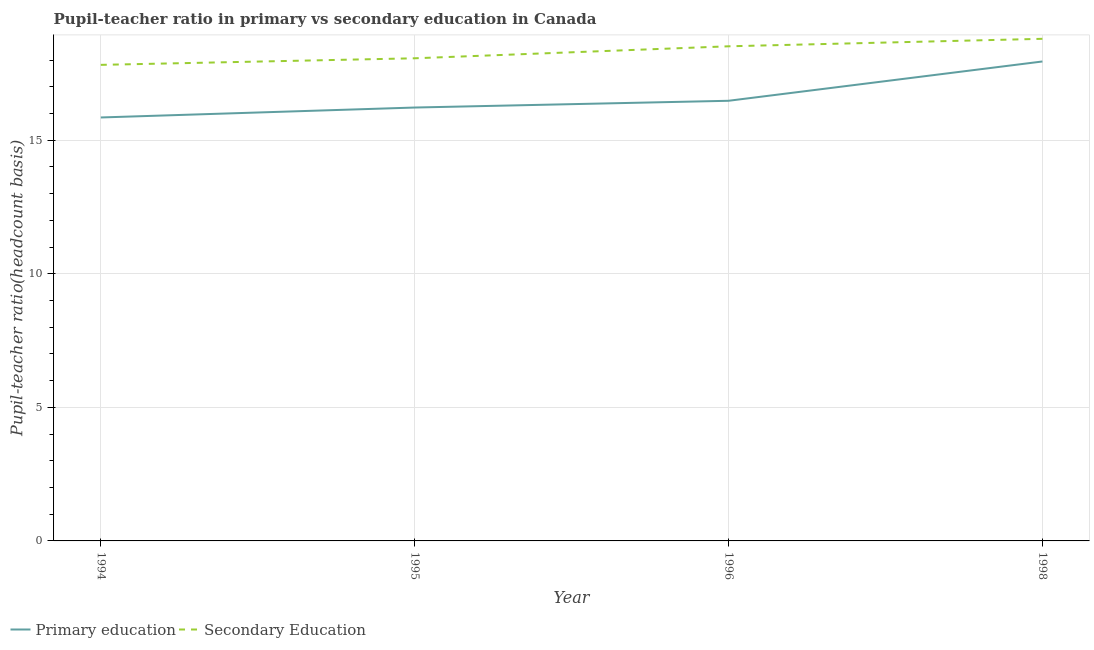Does the line corresponding to pupil-teacher ratio in primary education intersect with the line corresponding to pupil teacher ratio on secondary education?
Provide a succinct answer. No. Is the number of lines equal to the number of legend labels?
Ensure brevity in your answer.  Yes. What is the pupil-teacher ratio in primary education in 1994?
Give a very brief answer. 15.85. Across all years, what is the maximum pupil teacher ratio on secondary education?
Keep it short and to the point. 18.8. Across all years, what is the minimum pupil teacher ratio on secondary education?
Keep it short and to the point. 17.82. In which year was the pupil-teacher ratio in primary education minimum?
Ensure brevity in your answer.  1994. What is the total pupil teacher ratio on secondary education in the graph?
Your answer should be very brief. 73.21. What is the difference between the pupil-teacher ratio in primary education in 1995 and that in 1996?
Your response must be concise. -0.25. What is the difference between the pupil-teacher ratio in primary education in 1996 and the pupil teacher ratio on secondary education in 1994?
Provide a short and direct response. -1.34. What is the average pupil teacher ratio on secondary education per year?
Offer a very short reply. 18.3. In the year 1996, what is the difference between the pupil-teacher ratio in primary education and pupil teacher ratio on secondary education?
Ensure brevity in your answer.  -2.04. What is the ratio of the pupil-teacher ratio in primary education in 1995 to that in 1996?
Your response must be concise. 0.98. Is the difference between the pupil-teacher ratio in primary education in 1996 and 1998 greater than the difference between the pupil teacher ratio on secondary education in 1996 and 1998?
Keep it short and to the point. No. What is the difference between the highest and the second highest pupil-teacher ratio in primary education?
Your response must be concise. 1.47. What is the difference between the highest and the lowest pupil teacher ratio on secondary education?
Your answer should be very brief. 0.98. In how many years, is the pupil teacher ratio on secondary education greater than the average pupil teacher ratio on secondary education taken over all years?
Your response must be concise. 2. Does the pupil-teacher ratio in primary education monotonically increase over the years?
Your response must be concise. Yes. Is the pupil teacher ratio on secondary education strictly greater than the pupil-teacher ratio in primary education over the years?
Your answer should be very brief. Yes. How many years are there in the graph?
Keep it short and to the point. 4. What is the difference between two consecutive major ticks on the Y-axis?
Give a very brief answer. 5. Are the values on the major ticks of Y-axis written in scientific E-notation?
Offer a very short reply. No. How are the legend labels stacked?
Provide a succinct answer. Horizontal. What is the title of the graph?
Give a very brief answer. Pupil-teacher ratio in primary vs secondary education in Canada. What is the label or title of the X-axis?
Provide a succinct answer. Year. What is the label or title of the Y-axis?
Your answer should be compact. Pupil-teacher ratio(headcount basis). What is the Pupil-teacher ratio(headcount basis) of Primary education in 1994?
Keep it short and to the point. 15.85. What is the Pupil-teacher ratio(headcount basis) of Secondary Education in 1994?
Offer a terse response. 17.82. What is the Pupil-teacher ratio(headcount basis) in Primary education in 1995?
Ensure brevity in your answer.  16.23. What is the Pupil-teacher ratio(headcount basis) of Secondary Education in 1995?
Your answer should be very brief. 18.07. What is the Pupil-teacher ratio(headcount basis) in Primary education in 1996?
Your response must be concise. 16.48. What is the Pupil-teacher ratio(headcount basis) in Secondary Education in 1996?
Offer a very short reply. 18.52. What is the Pupil-teacher ratio(headcount basis) of Primary education in 1998?
Your response must be concise. 17.95. What is the Pupil-teacher ratio(headcount basis) of Secondary Education in 1998?
Offer a very short reply. 18.8. Across all years, what is the maximum Pupil-teacher ratio(headcount basis) in Primary education?
Offer a very short reply. 17.95. Across all years, what is the maximum Pupil-teacher ratio(headcount basis) in Secondary Education?
Your response must be concise. 18.8. Across all years, what is the minimum Pupil-teacher ratio(headcount basis) in Primary education?
Keep it short and to the point. 15.85. Across all years, what is the minimum Pupil-teacher ratio(headcount basis) in Secondary Education?
Your response must be concise. 17.82. What is the total Pupil-teacher ratio(headcount basis) of Primary education in the graph?
Provide a succinct answer. 66.51. What is the total Pupil-teacher ratio(headcount basis) of Secondary Education in the graph?
Make the answer very short. 73.21. What is the difference between the Pupil-teacher ratio(headcount basis) of Primary education in 1994 and that in 1995?
Your answer should be compact. -0.37. What is the difference between the Pupil-teacher ratio(headcount basis) in Secondary Education in 1994 and that in 1995?
Offer a terse response. -0.25. What is the difference between the Pupil-teacher ratio(headcount basis) of Primary education in 1994 and that in 1996?
Make the answer very short. -0.62. What is the difference between the Pupil-teacher ratio(headcount basis) in Secondary Education in 1994 and that in 1996?
Provide a short and direct response. -0.7. What is the difference between the Pupil-teacher ratio(headcount basis) of Primary education in 1994 and that in 1998?
Ensure brevity in your answer.  -2.1. What is the difference between the Pupil-teacher ratio(headcount basis) in Secondary Education in 1994 and that in 1998?
Ensure brevity in your answer.  -0.98. What is the difference between the Pupil-teacher ratio(headcount basis) in Primary education in 1995 and that in 1996?
Make the answer very short. -0.25. What is the difference between the Pupil-teacher ratio(headcount basis) in Secondary Education in 1995 and that in 1996?
Provide a short and direct response. -0.45. What is the difference between the Pupil-teacher ratio(headcount basis) of Primary education in 1995 and that in 1998?
Offer a very short reply. -1.72. What is the difference between the Pupil-teacher ratio(headcount basis) of Secondary Education in 1995 and that in 1998?
Ensure brevity in your answer.  -0.73. What is the difference between the Pupil-teacher ratio(headcount basis) in Primary education in 1996 and that in 1998?
Make the answer very short. -1.47. What is the difference between the Pupil-teacher ratio(headcount basis) of Secondary Education in 1996 and that in 1998?
Keep it short and to the point. -0.28. What is the difference between the Pupil-teacher ratio(headcount basis) in Primary education in 1994 and the Pupil-teacher ratio(headcount basis) in Secondary Education in 1995?
Offer a terse response. -2.22. What is the difference between the Pupil-teacher ratio(headcount basis) of Primary education in 1994 and the Pupil-teacher ratio(headcount basis) of Secondary Education in 1996?
Provide a succinct answer. -2.66. What is the difference between the Pupil-teacher ratio(headcount basis) in Primary education in 1994 and the Pupil-teacher ratio(headcount basis) in Secondary Education in 1998?
Your response must be concise. -2.94. What is the difference between the Pupil-teacher ratio(headcount basis) of Primary education in 1995 and the Pupil-teacher ratio(headcount basis) of Secondary Education in 1996?
Give a very brief answer. -2.29. What is the difference between the Pupil-teacher ratio(headcount basis) in Primary education in 1995 and the Pupil-teacher ratio(headcount basis) in Secondary Education in 1998?
Offer a very short reply. -2.57. What is the difference between the Pupil-teacher ratio(headcount basis) of Primary education in 1996 and the Pupil-teacher ratio(headcount basis) of Secondary Education in 1998?
Ensure brevity in your answer.  -2.32. What is the average Pupil-teacher ratio(headcount basis) in Primary education per year?
Give a very brief answer. 16.63. What is the average Pupil-teacher ratio(headcount basis) of Secondary Education per year?
Ensure brevity in your answer.  18.3. In the year 1994, what is the difference between the Pupil-teacher ratio(headcount basis) of Primary education and Pupil-teacher ratio(headcount basis) of Secondary Education?
Your response must be concise. -1.97. In the year 1995, what is the difference between the Pupil-teacher ratio(headcount basis) of Primary education and Pupil-teacher ratio(headcount basis) of Secondary Education?
Provide a succinct answer. -1.84. In the year 1996, what is the difference between the Pupil-teacher ratio(headcount basis) of Primary education and Pupil-teacher ratio(headcount basis) of Secondary Education?
Make the answer very short. -2.04. In the year 1998, what is the difference between the Pupil-teacher ratio(headcount basis) in Primary education and Pupil-teacher ratio(headcount basis) in Secondary Education?
Your response must be concise. -0.85. What is the ratio of the Pupil-teacher ratio(headcount basis) in Primary education in 1994 to that in 1995?
Keep it short and to the point. 0.98. What is the ratio of the Pupil-teacher ratio(headcount basis) in Secondary Education in 1994 to that in 1995?
Your answer should be compact. 0.99. What is the ratio of the Pupil-teacher ratio(headcount basis) in Primary education in 1994 to that in 1996?
Provide a short and direct response. 0.96. What is the ratio of the Pupil-teacher ratio(headcount basis) of Secondary Education in 1994 to that in 1996?
Keep it short and to the point. 0.96. What is the ratio of the Pupil-teacher ratio(headcount basis) in Primary education in 1994 to that in 1998?
Your answer should be very brief. 0.88. What is the ratio of the Pupil-teacher ratio(headcount basis) of Secondary Education in 1994 to that in 1998?
Give a very brief answer. 0.95. What is the ratio of the Pupil-teacher ratio(headcount basis) in Primary education in 1995 to that in 1996?
Your answer should be compact. 0.98. What is the ratio of the Pupil-teacher ratio(headcount basis) in Secondary Education in 1995 to that in 1996?
Offer a very short reply. 0.98. What is the ratio of the Pupil-teacher ratio(headcount basis) in Primary education in 1995 to that in 1998?
Give a very brief answer. 0.9. What is the ratio of the Pupil-teacher ratio(headcount basis) in Secondary Education in 1995 to that in 1998?
Offer a terse response. 0.96. What is the ratio of the Pupil-teacher ratio(headcount basis) of Primary education in 1996 to that in 1998?
Your response must be concise. 0.92. What is the ratio of the Pupil-teacher ratio(headcount basis) of Secondary Education in 1996 to that in 1998?
Your answer should be very brief. 0.99. What is the difference between the highest and the second highest Pupil-teacher ratio(headcount basis) of Primary education?
Offer a very short reply. 1.47. What is the difference between the highest and the second highest Pupil-teacher ratio(headcount basis) of Secondary Education?
Provide a succinct answer. 0.28. What is the difference between the highest and the lowest Pupil-teacher ratio(headcount basis) in Primary education?
Provide a short and direct response. 2.1. What is the difference between the highest and the lowest Pupil-teacher ratio(headcount basis) of Secondary Education?
Your answer should be very brief. 0.98. 